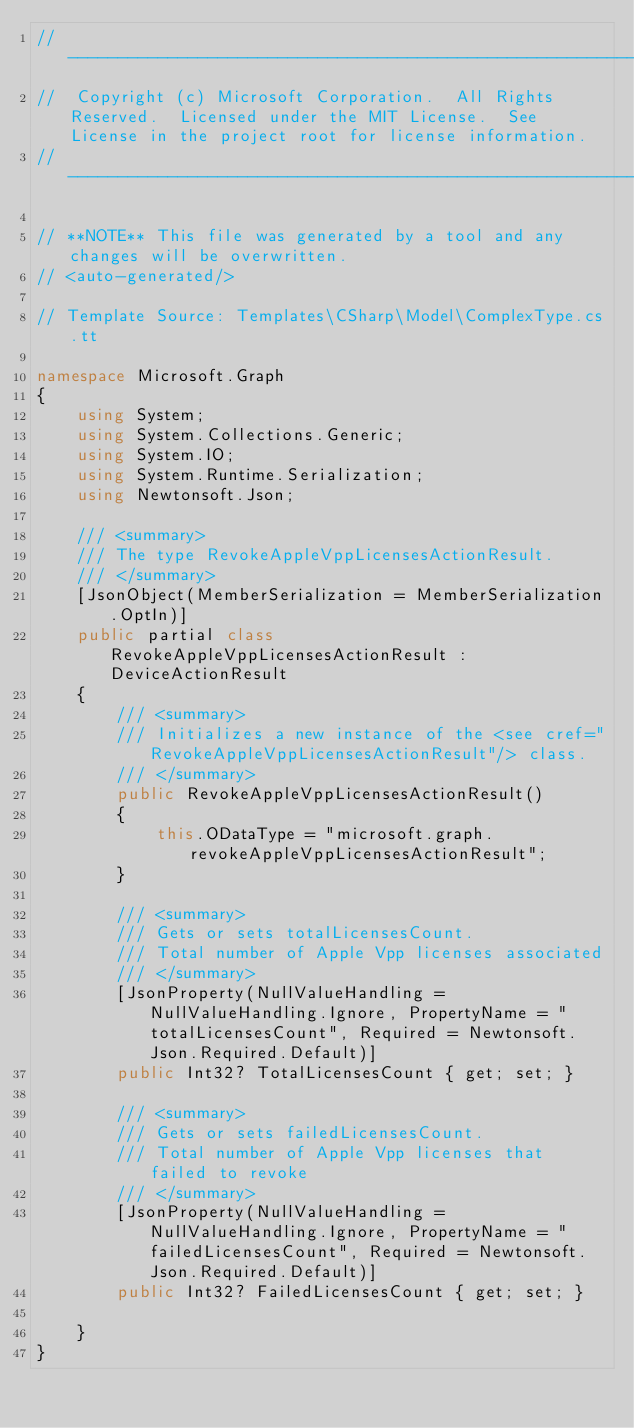<code> <loc_0><loc_0><loc_500><loc_500><_C#_>// ------------------------------------------------------------------------------
//  Copyright (c) Microsoft Corporation.  All Rights Reserved.  Licensed under the MIT License.  See License in the project root for license information.
// ------------------------------------------------------------------------------

// **NOTE** This file was generated by a tool and any changes will be overwritten.
// <auto-generated/>

// Template Source: Templates\CSharp\Model\ComplexType.cs.tt

namespace Microsoft.Graph
{
    using System;
    using System.Collections.Generic;
    using System.IO;
    using System.Runtime.Serialization;
    using Newtonsoft.Json;

    /// <summary>
    /// The type RevokeAppleVppLicensesActionResult.
    /// </summary>
    [JsonObject(MemberSerialization = MemberSerialization.OptIn)]
    public partial class RevokeAppleVppLicensesActionResult : DeviceActionResult
    {
        /// <summary>
        /// Initializes a new instance of the <see cref="RevokeAppleVppLicensesActionResult"/> class.
        /// </summary>
        public RevokeAppleVppLicensesActionResult()
        {
            this.ODataType = "microsoft.graph.revokeAppleVppLicensesActionResult";
        }

        /// <summary>
        /// Gets or sets totalLicensesCount.
        /// Total number of Apple Vpp licenses associated
        /// </summary>
        [JsonProperty(NullValueHandling = NullValueHandling.Ignore, PropertyName = "totalLicensesCount", Required = Newtonsoft.Json.Required.Default)]
        public Int32? TotalLicensesCount { get; set; }
    
        /// <summary>
        /// Gets or sets failedLicensesCount.
        /// Total number of Apple Vpp licenses that failed to revoke
        /// </summary>
        [JsonProperty(NullValueHandling = NullValueHandling.Ignore, PropertyName = "failedLicensesCount", Required = Newtonsoft.Json.Required.Default)]
        public Int32? FailedLicensesCount { get; set; }
    
    }
}
</code> 